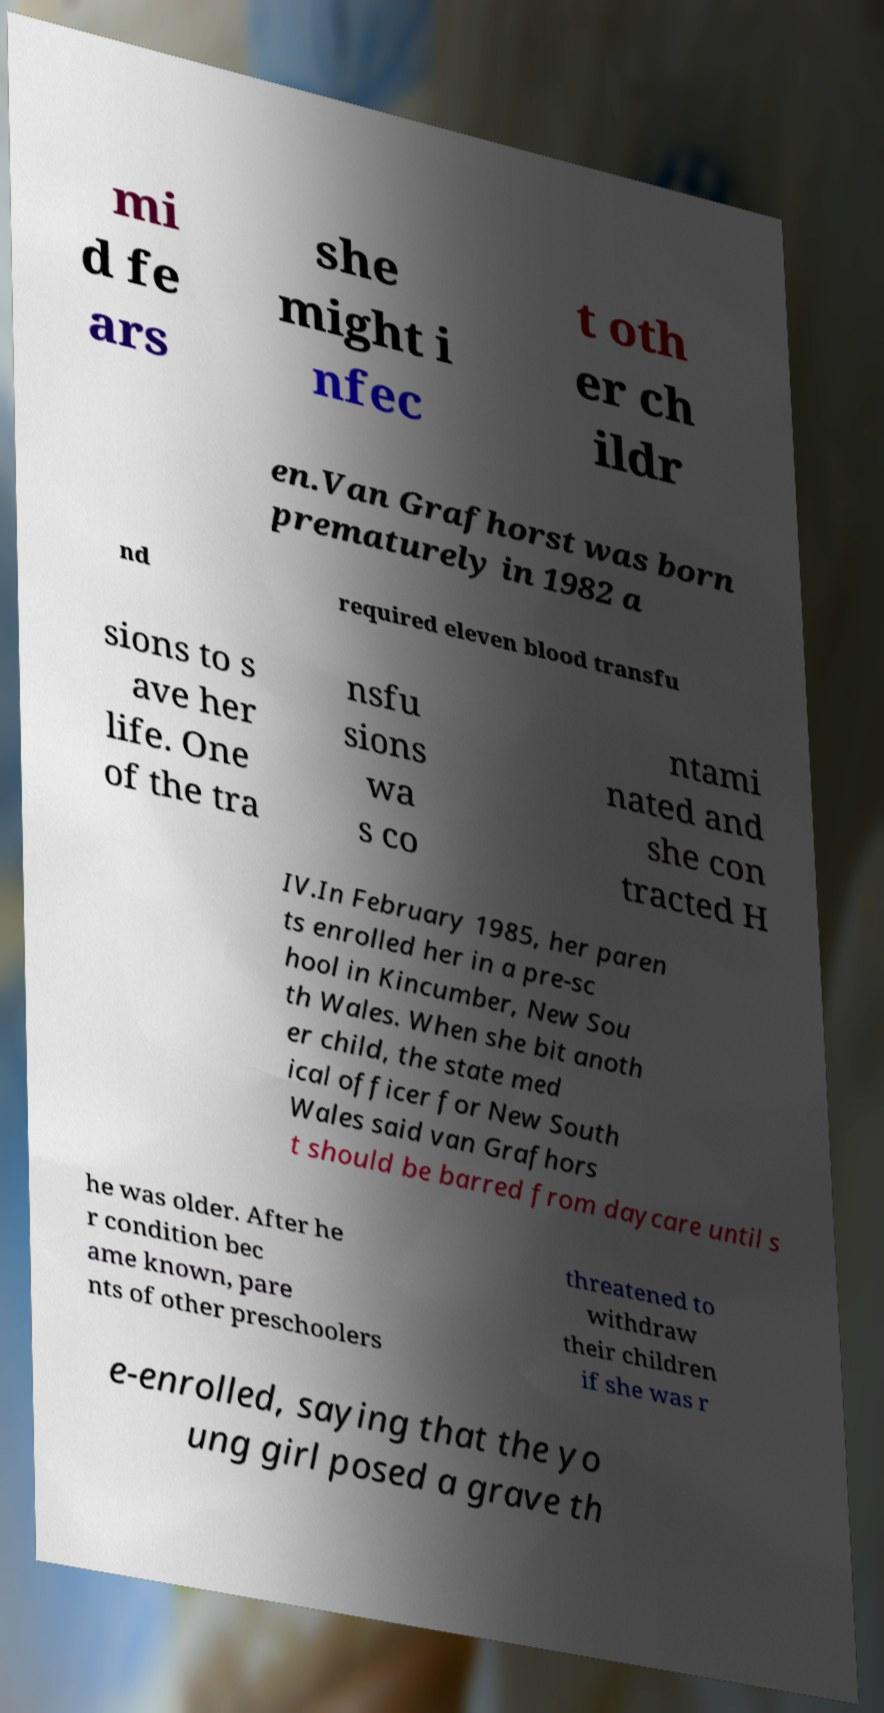What messages or text are displayed in this image? I need them in a readable, typed format. mi d fe ars she might i nfec t oth er ch ildr en.Van Grafhorst was born prematurely in 1982 a nd required eleven blood transfu sions to s ave her life. One of the tra nsfu sions wa s co ntami nated and she con tracted H IV.In February 1985, her paren ts enrolled her in a pre-sc hool in Kincumber, New Sou th Wales. When she bit anoth er child, the state med ical officer for New South Wales said van Grafhors t should be barred from daycare until s he was older. After he r condition bec ame known, pare nts of other preschoolers threatened to withdraw their children if she was r e-enrolled, saying that the yo ung girl posed a grave th 